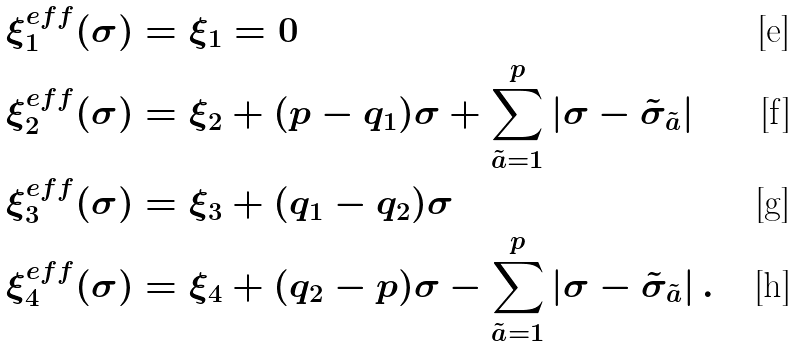Convert formula to latex. <formula><loc_0><loc_0><loc_500><loc_500>\xi _ { 1 } ^ { e f f } ( \sigma ) & = \xi _ { 1 } = 0 \\ \xi _ { 2 } ^ { e f f } ( \sigma ) & = \xi _ { 2 } + ( p - q _ { 1 } ) \sigma + \sum _ { \tilde { a } = 1 } ^ { p } | \sigma - \tilde { \sigma } _ { \tilde { a } } | \\ \xi _ { 3 } ^ { e f f } ( \sigma ) & = \xi _ { 3 } + ( q _ { 1 } - q _ { 2 } ) \sigma \\ \xi _ { 4 } ^ { e f f } ( \sigma ) & = \xi _ { 4 } + ( q _ { 2 } - p ) \sigma - \sum _ { \tilde { a } = 1 } ^ { p } | \sigma - \tilde { \sigma } _ { \tilde { a } } | \, .</formula> 